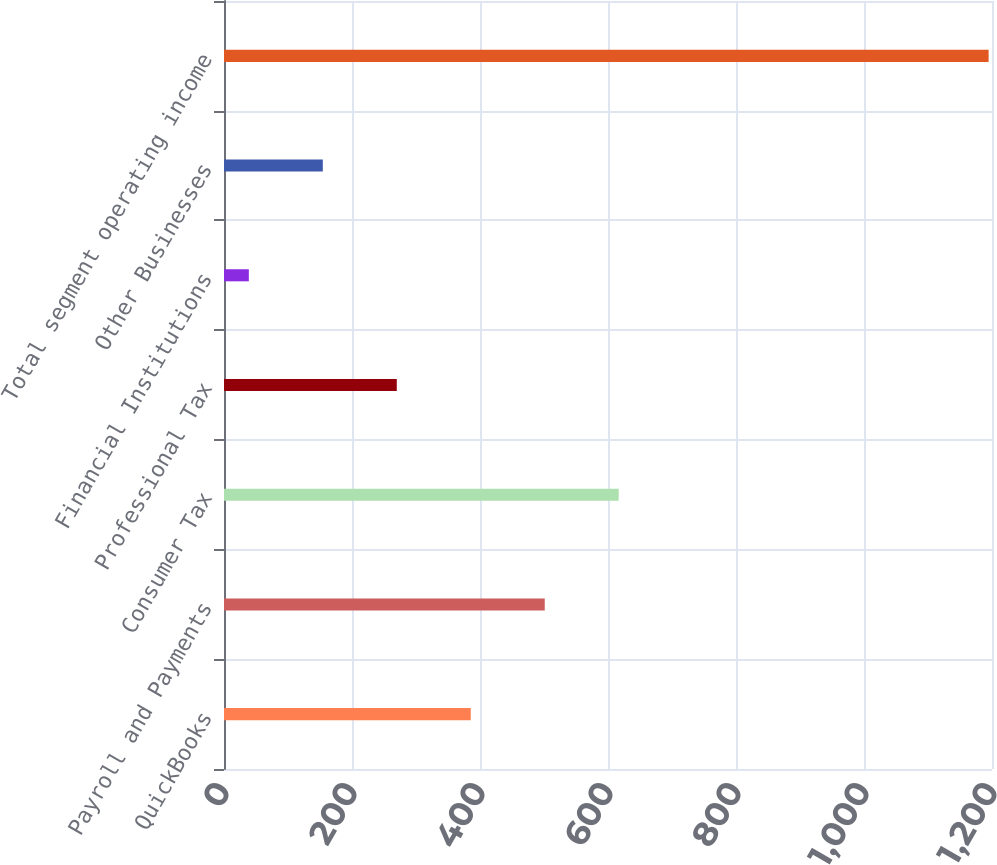<chart> <loc_0><loc_0><loc_500><loc_500><bar_chart><fcel>QuickBooks<fcel>Payroll and Payments<fcel>Consumer Tax<fcel>Professional Tax<fcel>Financial Institutions<fcel>Other Businesses<fcel>Total segment operating income<nl><fcel>385.57<fcel>501.16<fcel>616.75<fcel>269.98<fcel>38.8<fcel>154.39<fcel>1194.7<nl></chart> 